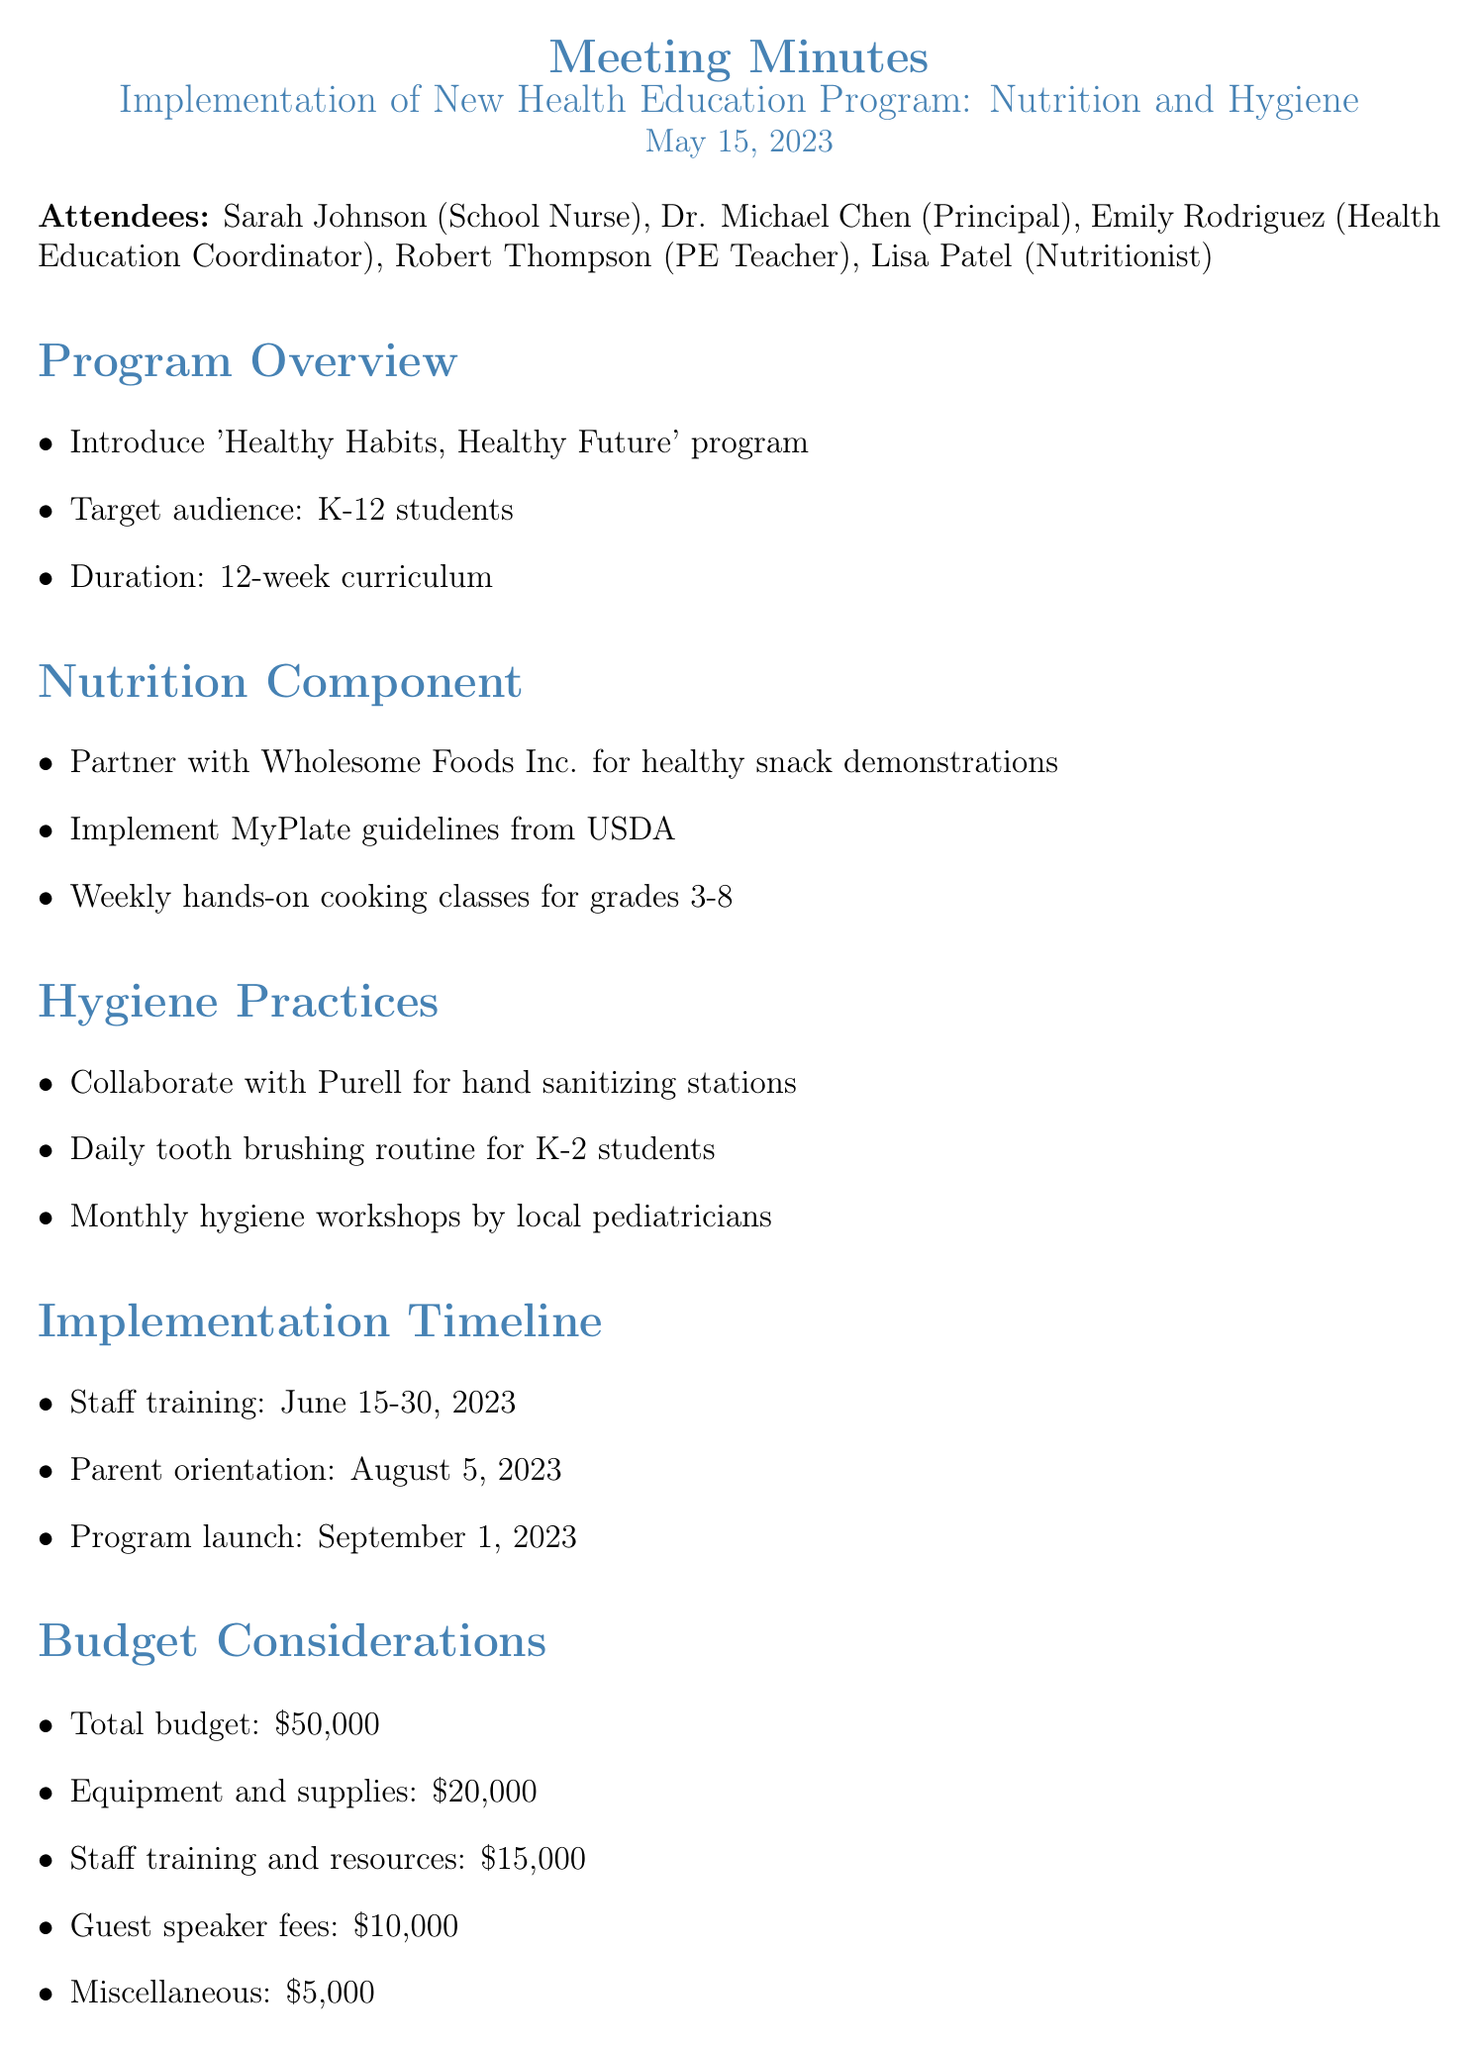What is the name of the program? The program is introduced as 'Healthy Habits, Healthy Future' in the document.
Answer: 'Healthy Habits, Healthy Future' Who will conduct the monthly hygiene workshops? The document states that local pediatricians will conduct the monthly hygiene workshops.
Answer: local pediatricians What is the total budget for the program? The total budget mentioned in the document is \$50,000.
Answer: \$50,000 When is the staff training scheduled? The document specifies that staff training is scheduled from June 15-30, 2023.
Answer: June 15-30, 2023 How long is the duration of the curriculum? The curriculum duration, as stated in the document, is 12 weeks.
Answer: 12 weeks Which organization is partnering for healthy snack demonstrations? The document mentions that Wholesome Foods Inc. is partnering for healthy snack demonstrations.
Answer: Wholesome Foods Inc What kind of assessments will be conducted quarterly? The document indicates that BMI and general health assessments will be conducted quarterly.
Answer: BMI and general health assessments Who is responsible for developing age-appropriate nutrition materials? Lisa Patel is assigned to develop age-appropriate nutrition materials by June 15 according to the document.
Answer: Lisa Patel 